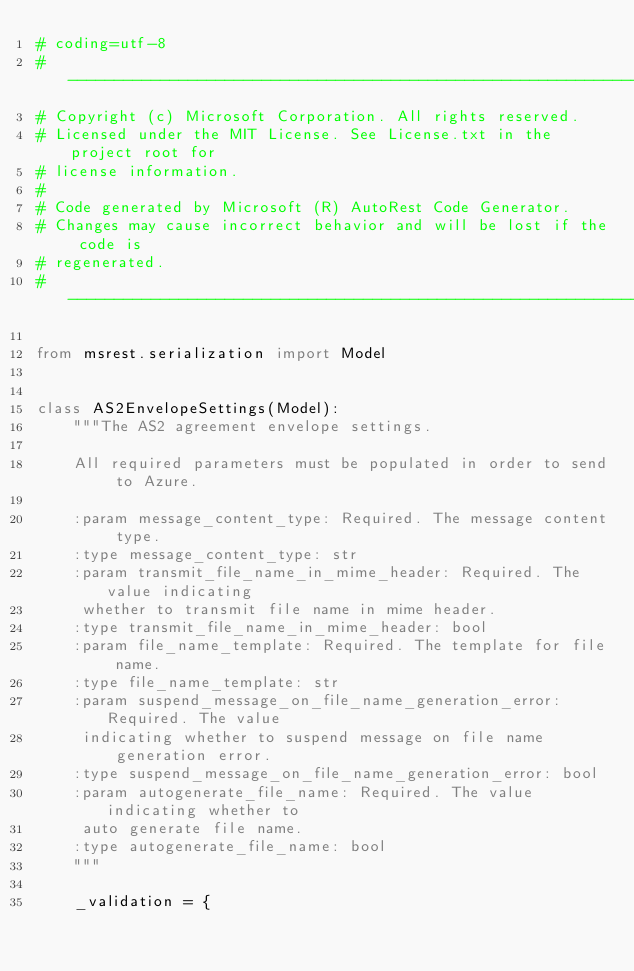<code> <loc_0><loc_0><loc_500><loc_500><_Python_># coding=utf-8
# --------------------------------------------------------------------------
# Copyright (c) Microsoft Corporation. All rights reserved.
# Licensed under the MIT License. See License.txt in the project root for
# license information.
#
# Code generated by Microsoft (R) AutoRest Code Generator.
# Changes may cause incorrect behavior and will be lost if the code is
# regenerated.
# --------------------------------------------------------------------------

from msrest.serialization import Model


class AS2EnvelopeSettings(Model):
    """The AS2 agreement envelope settings.

    All required parameters must be populated in order to send to Azure.

    :param message_content_type: Required. The message content type.
    :type message_content_type: str
    :param transmit_file_name_in_mime_header: Required. The value indicating
     whether to transmit file name in mime header.
    :type transmit_file_name_in_mime_header: bool
    :param file_name_template: Required. The template for file name.
    :type file_name_template: str
    :param suspend_message_on_file_name_generation_error: Required. The value
     indicating whether to suspend message on file name generation error.
    :type suspend_message_on_file_name_generation_error: bool
    :param autogenerate_file_name: Required. The value indicating whether to
     auto generate file name.
    :type autogenerate_file_name: bool
    """

    _validation = {</code> 